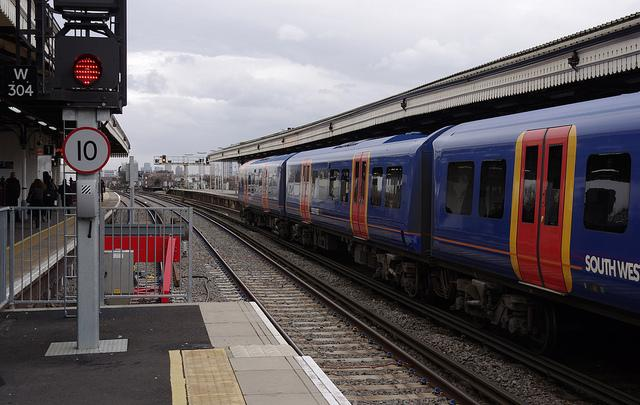What airline is advertised on the train? southwest 